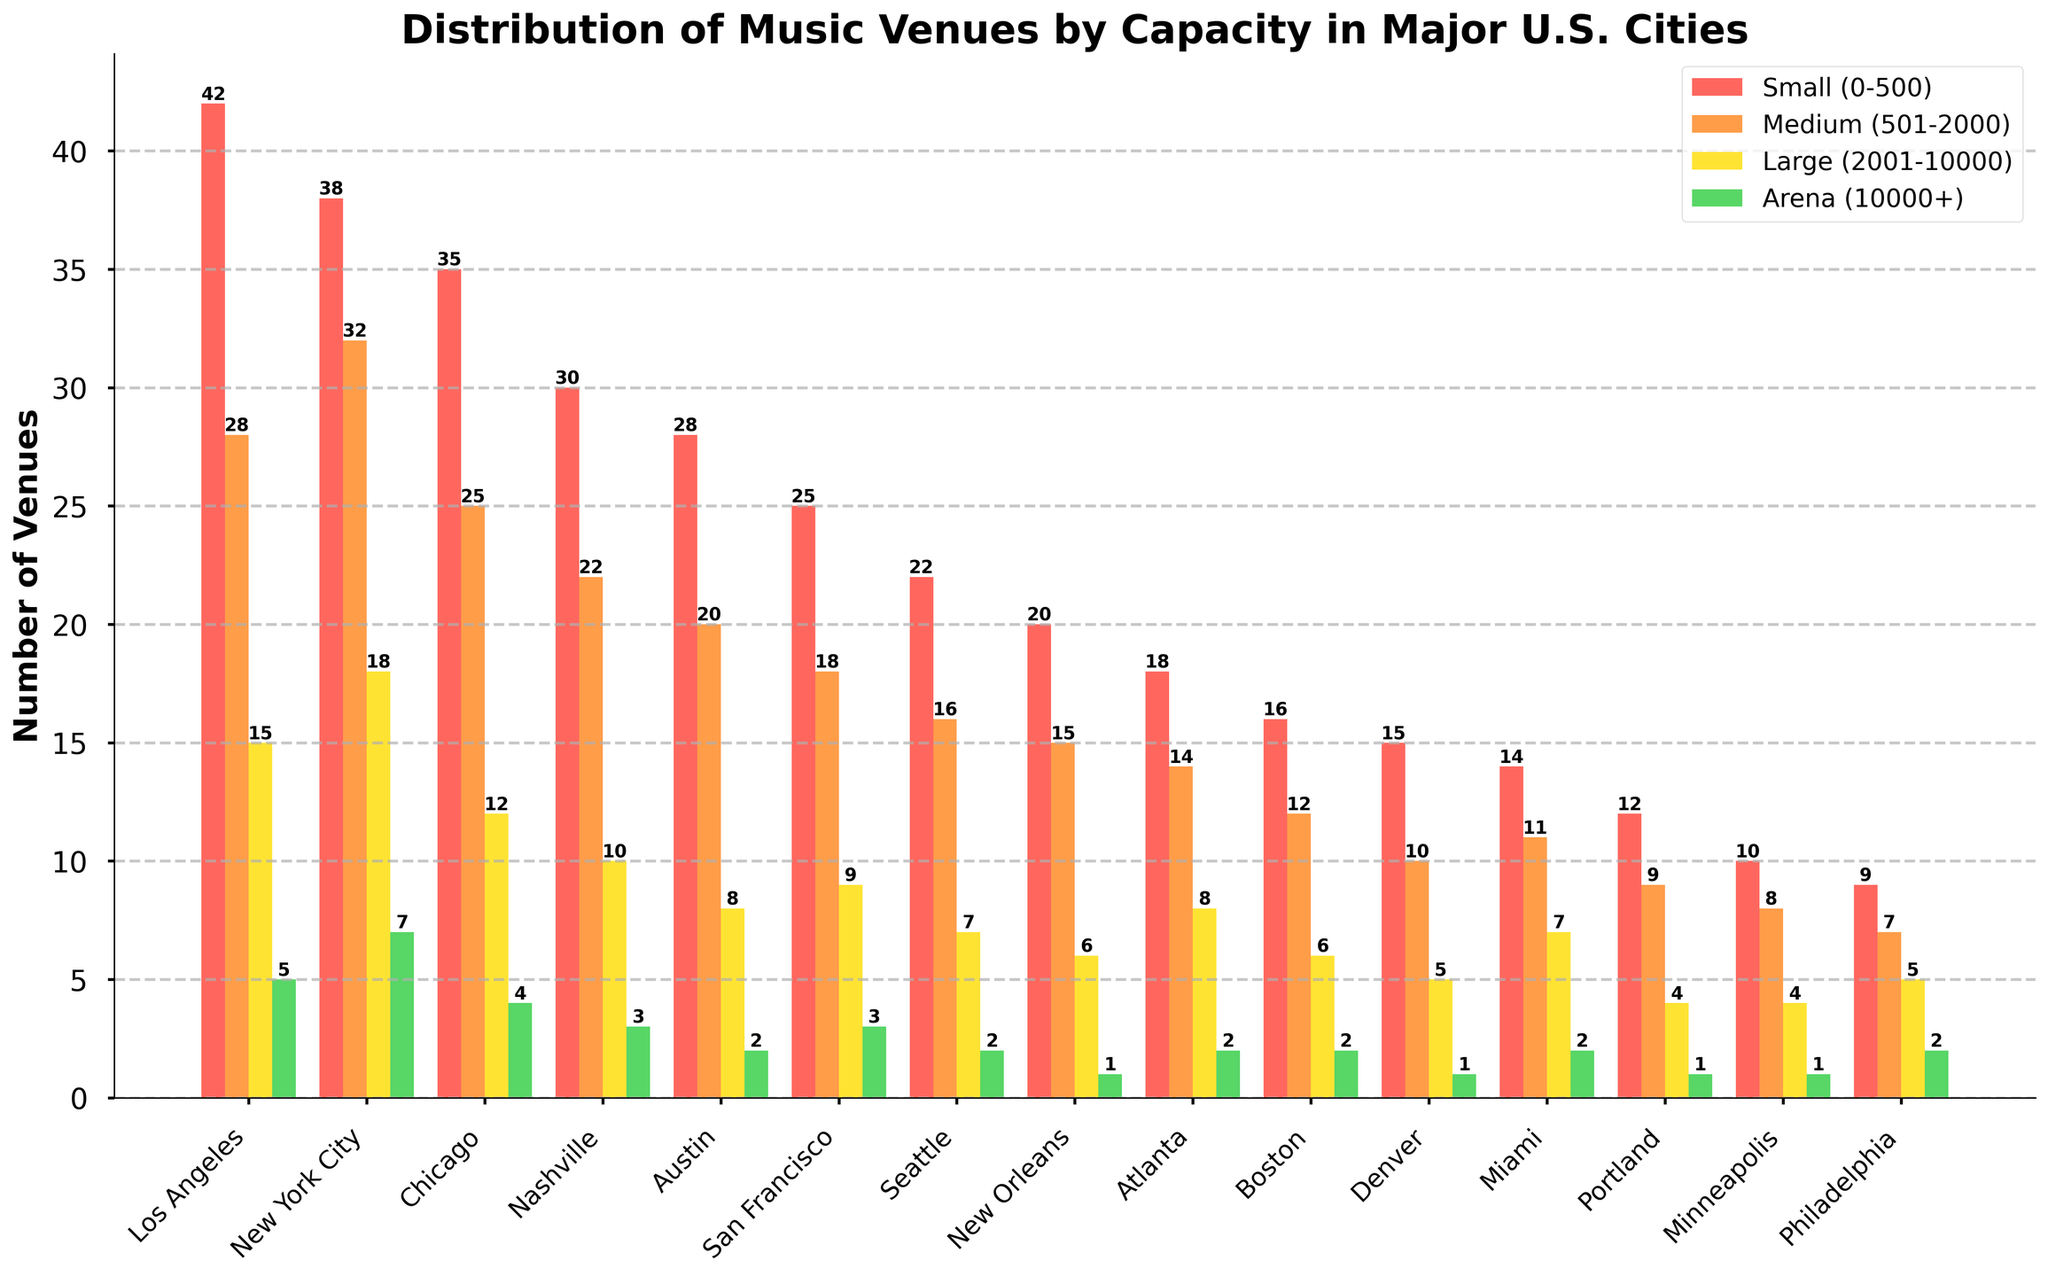Which city has the highest number of small venues suitable for tribute bands? The city with the highest number of small venues can be identified by finding the tallest red bar labeled 'Small (0-500)'. In this case, it's in Los Angeles with 42 venues.
Answer: Los Angeles In which city is the sum of large and arena venues greater than 20? Sum the values of 'Large (2001-10000)' and 'Arena (10000+)' for each city and check which totals exceed 20. Los Angeles (15+5=20), New York City (18+7=25) exceed this threshold.
Answer: New York City Which city has more medium venues than small venues? Compare the heights of the orange bars 'Medium (501-2000)' and red bars 'Small (0-500)' for each city. In New York City, the medium venues (32) exceed the small venues (38).
Answer: None How does the number of small venues compare between Austin and Nashville? Check the red bars labeled 'Small (0-500)' for Austin (28) and Nashville (30). Nashville has 2 more small venues than Austin.
Answer: Nashville has more by 2 Which city has the least number of large venues? Identify the city with the shortest yellow bar labeled 'Large (2001-10000)'. Philadelphia, Portland, and Minneapolis each have 4 large venues, which is the lowest among the cities.
Answer: Philadelphia, Portland, Minneapolis What is the total number of venues (all sizes) in Chicago? Add up bars for Chicago: Small (35) + Medium (25) + Large (12) + Arena (4) = 76.
Answer: 76 Are there more small venues than medium venues in most cities? Compare the red and orange bars across all cities. In most cities, the red bars ('Small') are taller than the orange bars ('Medium'), indicating more small venues.
Answer: Yes Which city has the second most number of medium venues suitable for tribute bands? Find the second tallest orange bar labeled 'Medium (501-2000)'. Los Angeles has the most (32), and New York City is second with 32.
Answer: New York City Which city has the highest combined total of large and arena venues? Add the values of 'Large (2001-10000)' and 'Arena (10000+)' for each city to identify the highest combined total. New York City has 18 (large) + 7 (arena) = 25, which is the highest.
Answer: New York City What is the difference in the number of small venues between Los Angeles and Denver? Subtract the number of small venues in Denver (15) from the number in Los Angeles (42): 42 - 15 = 27.
Answer: 27 